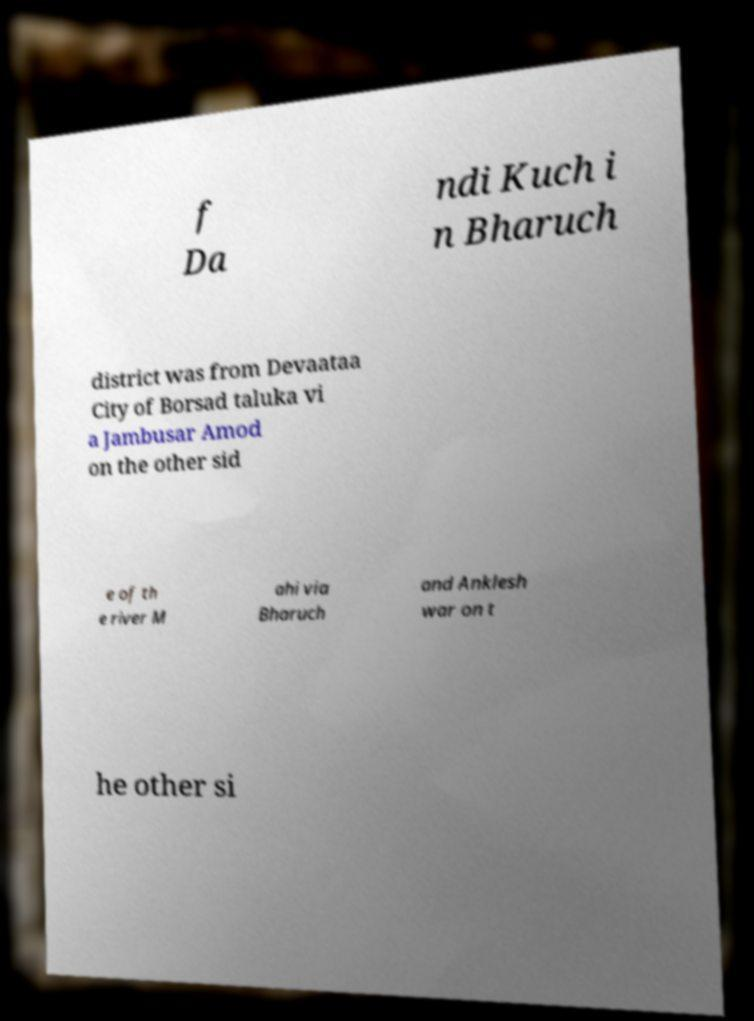What messages or text are displayed in this image? I need them in a readable, typed format. f Da ndi Kuch i n Bharuch district was from Devaataa City of Borsad taluka vi a Jambusar Amod on the other sid e of th e river M ahi via Bharuch and Anklesh war on t he other si 